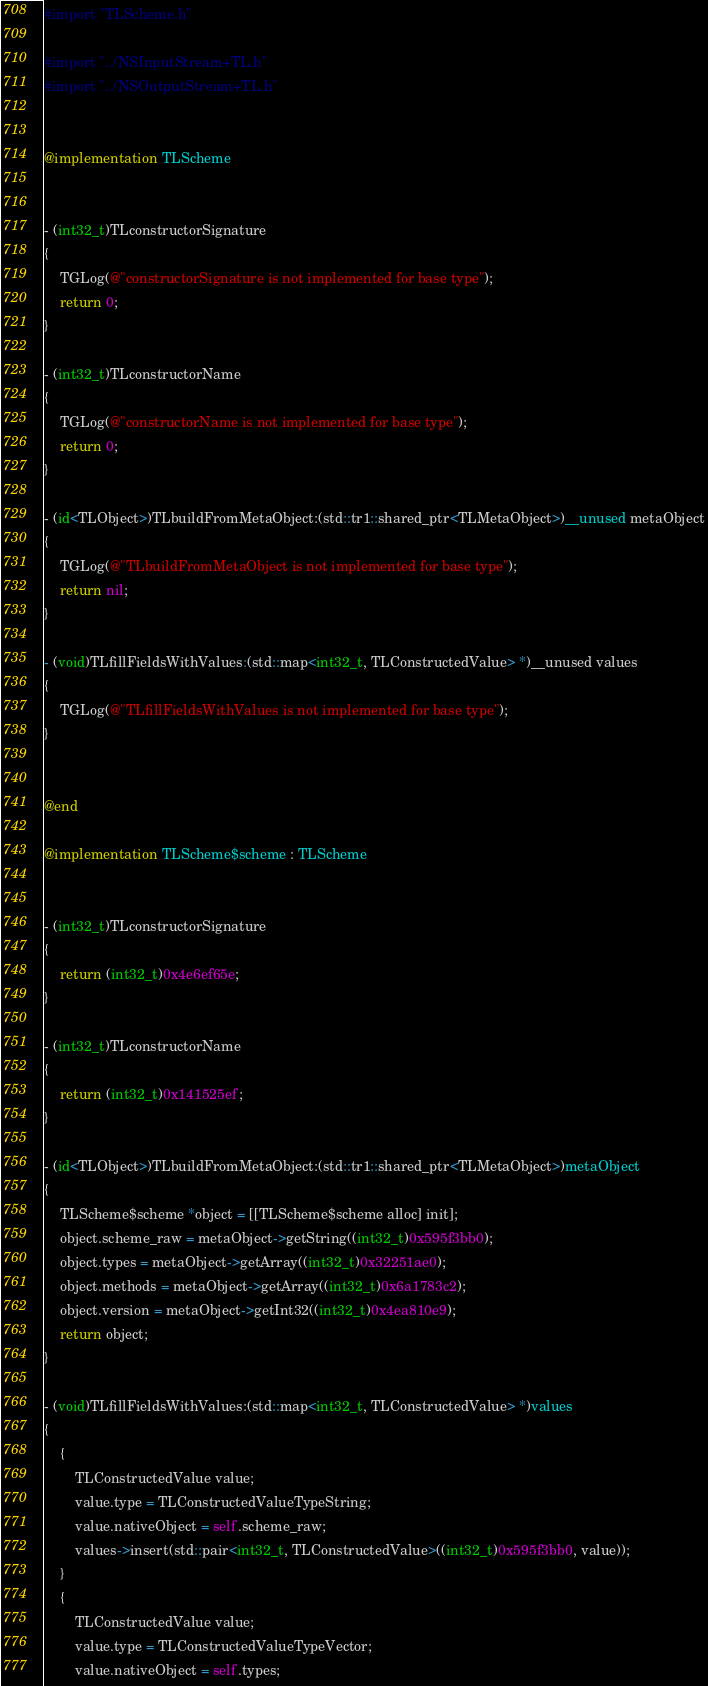<code> <loc_0><loc_0><loc_500><loc_500><_ObjectiveC_>#import "TLScheme.h"

#import "../NSInputStream+TL.h"
#import "../NSOutputStream+TL.h"


@implementation TLScheme


- (int32_t)TLconstructorSignature
{
    TGLog(@"constructorSignature is not implemented for base type");
    return 0;
}

- (int32_t)TLconstructorName
{
    TGLog(@"constructorName is not implemented for base type");
    return 0;
}

- (id<TLObject>)TLbuildFromMetaObject:(std::tr1::shared_ptr<TLMetaObject>)__unused metaObject
{
    TGLog(@"TLbuildFromMetaObject is not implemented for base type");
    return nil;
}

- (void)TLfillFieldsWithValues:(std::map<int32_t, TLConstructedValue> *)__unused values
{
    TGLog(@"TLfillFieldsWithValues is not implemented for base type");
}


@end

@implementation TLScheme$scheme : TLScheme


- (int32_t)TLconstructorSignature
{
    return (int32_t)0x4e6ef65e;
}

- (int32_t)TLconstructorName
{
    return (int32_t)0x141525ef;
}

- (id<TLObject>)TLbuildFromMetaObject:(std::tr1::shared_ptr<TLMetaObject>)metaObject
{
    TLScheme$scheme *object = [[TLScheme$scheme alloc] init];
    object.scheme_raw = metaObject->getString((int32_t)0x595f3bb0);
    object.types = metaObject->getArray((int32_t)0x32251ae0);
    object.methods = metaObject->getArray((int32_t)0x6a1783c2);
    object.version = metaObject->getInt32((int32_t)0x4ea810e9);
    return object;
}

- (void)TLfillFieldsWithValues:(std::map<int32_t, TLConstructedValue> *)values
{
    {
        TLConstructedValue value;
        value.type = TLConstructedValueTypeString;
        value.nativeObject = self.scheme_raw;
        values->insert(std::pair<int32_t, TLConstructedValue>((int32_t)0x595f3bb0, value));
    }
    {
        TLConstructedValue value;
        value.type = TLConstructedValueTypeVector;
        value.nativeObject = self.types;</code> 